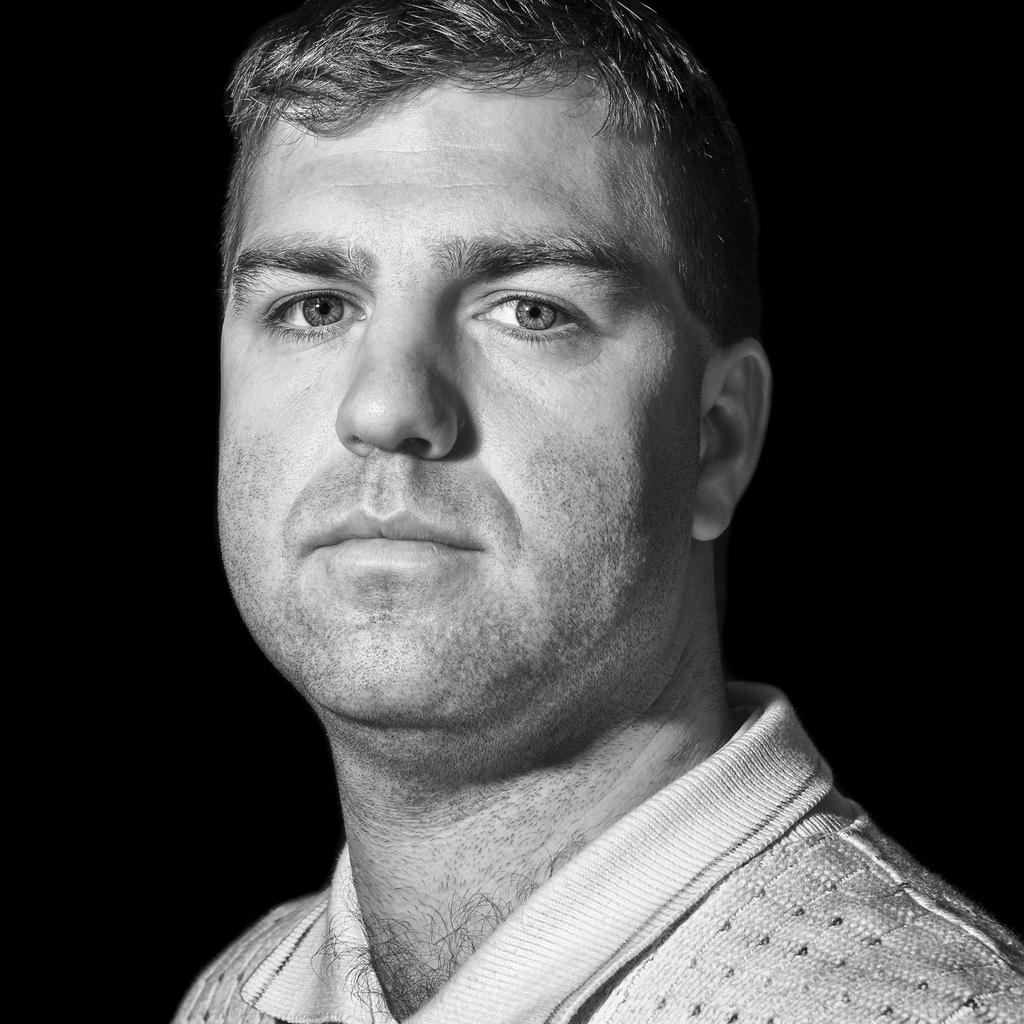What is the main subject of the image? The main subject of the image is a photograph of a man. What is the man wearing in the image? The man is wearing a white t-shirt in the image. What is the man doing in the image? The man is looking into the camera and giving a pose in the image. What is the color of the background in the image? The background in the image is black. What type of creature can be seen in the market in the image? There is no market or creature present in the image; it features a photograph of a man wearing a white t-shirt and looking into the camera. 